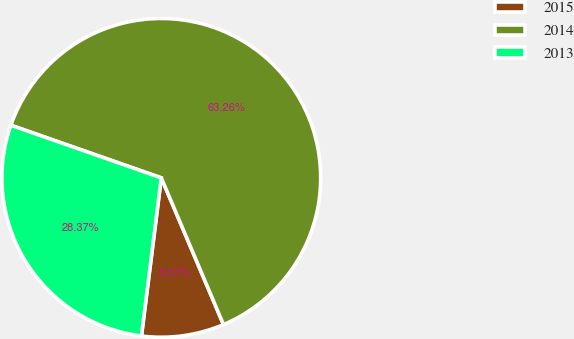Convert chart. <chart><loc_0><loc_0><loc_500><loc_500><pie_chart><fcel>2015<fcel>2014<fcel>2013<nl><fcel>8.37%<fcel>63.26%<fcel>28.37%<nl></chart> 